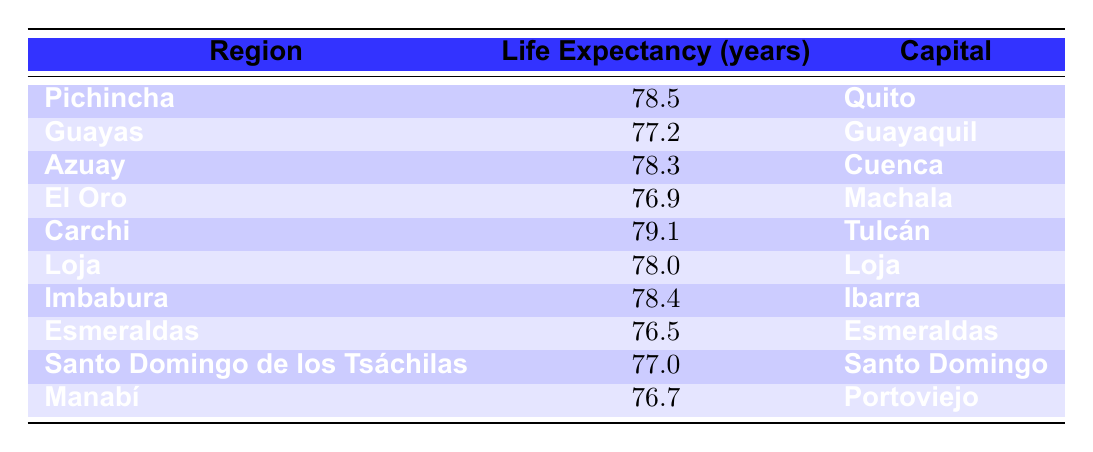What is the life expectancy in the region of Carchi? The table lists Carchi as having a life expectancy of 79.1 years. This value is directly retrieved from the appropriate cell in the table.
Answer: 79.1 Which region has the lowest life expectancy? Looking through the table, Esmeraldas has the lowest life expectancy at 76.5 years. This is identified by comparing the life expectancy values across all regions listed.
Answer: Esmeraldas What is the average life expectancy of the regions listed? To find the average, I will first sum the life expectancy values (78.5 + 77.2 + 78.3 + 76.9 + 79.1 + 78.0 + 78.4 + 76.5 + 77.0 + 76.7 = 778.6), then divide by the number of regions (10). Thus, the average is 778.6 / 10 = 77.86.
Answer: 77.86 Is the life expectancy in Loja greater than that in Guayas? In the table, Loja's life expectancy is 78.0 years and Guayas' is 77.2 years. Comparing these two values shows that 78.0 is indeed greater than 77.2. Therefore, the statement is true.
Answer: Yes How many regions have a life expectancy greater than 78 years? By examining the life expectancy values, I find that three regions (Carchi, Pichincha, Azuay, and Imbabura) have life expectancies above 78 years. The regions and their values are (Carchi - 79.1, Pichincha - 78.5, Azuay - 78.3, and Imbabura - 78.4). Counting these yields four regions.
Answer: 4 Which capital has the highest life expectancy among the regions? The capitals listed in the table are Quito, Guayaquil, Cuenca, Machala, Tulcán, Loja, Ibarra, Esmeraldas, Santo Domingo, and Portoviejo. The corresponding highest life expectancy is in Quito with 78.5 years. This requires checking the life expectancy next to each capital.
Answer: Quito Is Azuay's life expectancy lower than that of El Oro? Azuay has a life expectancy of 78.3 years while El Oro has 76.9 years. Comparing these two shows that 78.3 is greater than 76.9, thus the statement is false.
Answer: No What is the difference in life expectancy between Carchi and Esmeraldas? The life expectancy for Carchi is 79.1 years and for Esmeraldas, it is 76.5 years. To find the difference, I calculate (79.1 - 76.5 = 2.6). This is a straightforward subtraction between the two regions' values.
Answer: 2.6 How does the life expectancy of Santo Domingo compare to the average life expectancy? Santo Domingo has a life expectancy of 77.0 years. As previously calculated, the average life expectancy is 77.86 years. Comparing these two shows that 77.0 is less than 77.86. Therefore, Santo Domingo's life expectancy is below average.
Answer: Below average 